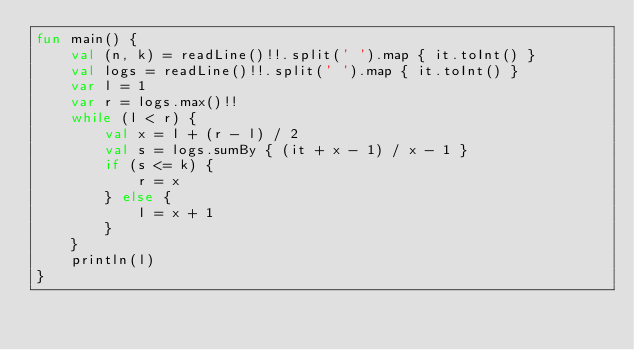Convert code to text. <code><loc_0><loc_0><loc_500><loc_500><_Kotlin_>fun main() {
    val (n, k) = readLine()!!.split(' ').map { it.toInt() }
    val logs = readLine()!!.split(' ').map { it.toInt() }
    var l = 1
    var r = logs.max()!!
    while (l < r) {
        val x = l + (r - l) / 2
        val s = logs.sumBy { (it + x - 1) / x - 1 }
        if (s <= k) {
            r = x
        } else {
            l = x + 1
        }
    }
    println(l)
}
</code> 